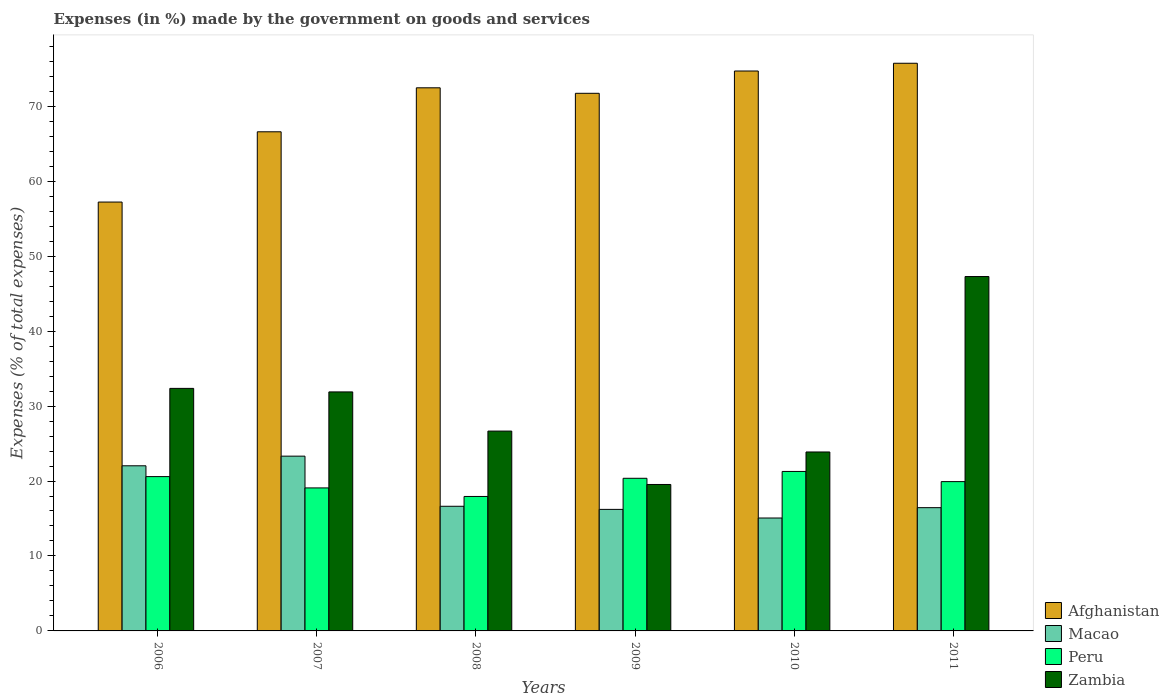How many groups of bars are there?
Your answer should be compact. 6. Are the number of bars on each tick of the X-axis equal?
Provide a short and direct response. Yes. How many bars are there on the 4th tick from the left?
Provide a short and direct response. 4. How many bars are there on the 4th tick from the right?
Give a very brief answer. 4. What is the percentage of expenses made by the government on goods and services in Zambia in 2009?
Ensure brevity in your answer.  19.54. Across all years, what is the maximum percentage of expenses made by the government on goods and services in Peru?
Ensure brevity in your answer.  21.28. Across all years, what is the minimum percentage of expenses made by the government on goods and services in Zambia?
Provide a short and direct response. 19.54. In which year was the percentage of expenses made by the government on goods and services in Zambia maximum?
Provide a succinct answer. 2011. What is the total percentage of expenses made by the government on goods and services in Afghanistan in the graph?
Your answer should be very brief. 418.42. What is the difference between the percentage of expenses made by the government on goods and services in Zambia in 2006 and that in 2007?
Your answer should be compact. 0.47. What is the difference between the percentage of expenses made by the government on goods and services in Afghanistan in 2008 and the percentage of expenses made by the government on goods and services in Zambia in 2006?
Offer a terse response. 40.1. What is the average percentage of expenses made by the government on goods and services in Zambia per year?
Provide a succinct answer. 30.27. In the year 2008, what is the difference between the percentage of expenses made by the government on goods and services in Zambia and percentage of expenses made by the government on goods and services in Afghanistan?
Keep it short and to the point. -45.8. What is the ratio of the percentage of expenses made by the government on goods and services in Peru in 2009 to that in 2010?
Provide a succinct answer. 0.96. Is the difference between the percentage of expenses made by the government on goods and services in Zambia in 2007 and 2010 greater than the difference between the percentage of expenses made by the government on goods and services in Afghanistan in 2007 and 2010?
Your response must be concise. Yes. What is the difference between the highest and the second highest percentage of expenses made by the government on goods and services in Zambia?
Keep it short and to the point. 14.92. What is the difference between the highest and the lowest percentage of expenses made by the government on goods and services in Peru?
Ensure brevity in your answer.  3.34. Is the sum of the percentage of expenses made by the government on goods and services in Zambia in 2008 and 2010 greater than the maximum percentage of expenses made by the government on goods and services in Peru across all years?
Give a very brief answer. Yes. What does the 4th bar from the left in 2007 represents?
Your answer should be very brief. Zambia. What does the 1st bar from the right in 2009 represents?
Offer a very short reply. Zambia. Is it the case that in every year, the sum of the percentage of expenses made by the government on goods and services in Afghanistan and percentage of expenses made by the government on goods and services in Peru is greater than the percentage of expenses made by the government on goods and services in Macao?
Offer a very short reply. Yes. How many bars are there?
Offer a very short reply. 24. Are all the bars in the graph horizontal?
Provide a succinct answer. No. Where does the legend appear in the graph?
Your answer should be compact. Bottom right. How many legend labels are there?
Provide a short and direct response. 4. What is the title of the graph?
Give a very brief answer. Expenses (in %) made by the government on goods and services. What is the label or title of the X-axis?
Give a very brief answer. Years. What is the label or title of the Y-axis?
Keep it short and to the point. Expenses (% of total expenses). What is the Expenses (% of total expenses) in Afghanistan in 2006?
Keep it short and to the point. 57.22. What is the Expenses (% of total expenses) in Macao in 2006?
Offer a very short reply. 22.03. What is the Expenses (% of total expenses) of Peru in 2006?
Provide a short and direct response. 20.59. What is the Expenses (% of total expenses) in Zambia in 2006?
Provide a succinct answer. 32.36. What is the Expenses (% of total expenses) in Afghanistan in 2007?
Provide a succinct answer. 66.59. What is the Expenses (% of total expenses) of Macao in 2007?
Keep it short and to the point. 23.32. What is the Expenses (% of total expenses) of Peru in 2007?
Ensure brevity in your answer.  19.08. What is the Expenses (% of total expenses) of Zambia in 2007?
Offer a very short reply. 31.89. What is the Expenses (% of total expenses) of Afghanistan in 2008?
Provide a succinct answer. 72.46. What is the Expenses (% of total expenses) in Macao in 2008?
Offer a terse response. 16.63. What is the Expenses (% of total expenses) in Peru in 2008?
Your response must be concise. 17.94. What is the Expenses (% of total expenses) of Zambia in 2008?
Make the answer very short. 26.66. What is the Expenses (% of total expenses) of Afghanistan in 2009?
Keep it short and to the point. 71.72. What is the Expenses (% of total expenses) in Macao in 2009?
Keep it short and to the point. 16.21. What is the Expenses (% of total expenses) in Peru in 2009?
Keep it short and to the point. 20.36. What is the Expenses (% of total expenses) of Zambia in 2009?
Make the answer very short. 19.54. What is the Expenses (% of total expenses) of Afghanistan in 2010?
Offer a very short reply. 74.7. What is the Expenses (% of total expenses) in Macao in 2010?
Your answer should be very brief. 15.06. What is the Expenses (% of total expenses) in Peru in 2010?
Offer a very short reply. 21.28. What is the Expenses (% of total expenses) in Zambia in 2010?
Offer a very short reply. 23.87. What is the Expenses (% of total expenses) in Afghanistan in 2011?
Ensure brevity in your answer.  75.73. What is the Expenses (% of total expenses) in Macao in 2011?
Offer a very short reply. 16.44. What is the Expenses (% of total expenses) in Peru in 2011?
Ensure brevity in your answer.  19.92. What is the Expenses (% of total expenses) of Zambia in 2011?
Ensure brevity in your answer.  47.28. Across all years, what is the maximum Expenses (% of total expenses) of Afghanistan?
Make the answer very short. 75.73. Across all years, what is the maximum Expenses (% of total expenses) of Macao?
Make the answer very short. 23.32. Across all years, what is the maximum Expenses (% of total expenses) in Peru?
Your answer should be compact. 21.28. Across all years, what is the maximum Expenses (% of total expenses) of Zambia?
Ensure brevity in your answer.  47.28. Across all years, what is the minimum Expenses (% of total expenses) of Afghanistan?
Your answer should be very brief. 57.22. Across all years, what is the minimum Expenses (% of total expenses) of Macao?
Your answer should be compact. 15.06. Across all years, what is the minimum Expenses (% of total expenses) of Peru?
Provide a succinct answer. 17.94. Across all years, what is the minimum Expenses (% of total expenses) in Zambia?
Make the answer very short. 19.54. What is the total Expenses (% of total expenses) of Afghanistan in the graph?
Provide a succinct answer. 418.42. What is the total Expenses (% of total expenses) in Macao in the graph?
Provide a succinct answer. 109.7. What is the total Expenses (% of total expenses) in Peru in the graph?
Keep it short and to the point. 119.16. What is the total Expenses (% of total expenses) of Zambia in the graph?
Your answer should be compact. 181.59. What is the difference between the Expenses (% of total expenses) of Afghanistan in 2006 and that in 2007?
Your response must be concise. -9.37. What is the difference between the Expenses (% of total expenses) in Macao in 2006 and that in 2007?
Offer a very short reply. -1.29. What is the difference between the Expenses (% of total expenses) of Peru in 2006 and that in 2007?
Give a very brief answer. 1.51. What is the difference between the Expenses (% of total expenses) in Zambia in 2006 and that in 2007?
Provide a succinct answer. 0.47. What is the difference between the Expenses (% of total expenses) in Afghanistan in 2006 and that in 2008?
Keep it short and to the point. -15.24. What is the difference between the Expenses (% of total expenses) in Macao in 2006 and that in 2008?
Keep it short and to the point. 5.4. What is the difference between the Expenses (% of total expenses) in Peru in 2006 and that in 2008?
Ensure brevity in your answer.  2.65. What is the difference between the Expenses (% of total expenses) of Zambia in 2006 and that in 2008?
Your answer should be compact. 5.7. What is the difference between the Expenses (% of total expenses) of Afghanistan in 2006 and that in 2009?
Your answer should be compact. -14.51. What is the difference between the Expenses (% of total expenses) in Macao in 2006 and that in 2009?
Offer a very short reply. 5.82. What is the difference between the Expenses (% of total expenses) in Peru in 2006 and that in 2009?
Provide a short and direct response. 0.22. What is the difference between the Expenses (% of total expenses) of Zambia in 2006 and that in 2009?
Provide a short and direct response. 12.82. What is the difference between the Expenses (% of total expenses) in Afghanistan in 2006 and that in 2010?
Make the answer very short. -17.48. What is the difference between the Expenses (% of total expenses) in Macao in 2006 and that in 2010?
Your response must be concise. 6.97. What is the difference between the Expenses (% of total expenses) of Peru in 2006 and that in 2010?
Provide a short and direct response. -0.69. What is the difference between the Expenses (% of total expenses) of Zambia in 2006 and that in 2010?
Provide a succinct answer. 8.48. What is the difference between the Expenses (% of total expenses) in Afghanistan in 2006 and that in 2011?
Provide a short and direct response. -18.52. What is the difference between the Expenses (% of total expenses) of Macao in 2006 and that in 2011?
Provide a succinct answer. 5.59. What is the difference between the Expenses (% of total expenses) in Peru in 2006 and that in 2011?
Offer a terse response. 0.67. What is the difference between the Expenses (% of total expenses) in Zambia in 2006 and that in 2011?
Keep it short and to the point. -14.92. What is the difference between the Expenses (% of total expenses) of Afghanistan in 2007 and that in 2008?
Provide a succinct answer. -5.87. What is the difference between the Expenses (% of total expenses) in Macao in 2007 and that in 2008?
Provide a succinct answer. 6.69. What is the difference between the Expenses (% of total expenses) in Peru in 2007 and that in 2008?
Give a very brief answer. 1.14. What is the difference between the Expenses (% of total expenses) of Zambia in 2007 and that in 2008?
Keep it short and to the point. 5.23. What is the difference between the Expenses (% of total expenses) in Afghanistan in 2007 and that in 2009?
Provide a short and direct response. -5.13. What is the difference between the Expenses (% of total expenses) of Macao in 2007 and that in 2009?
Your answer should be very brief. 7.1. What is the difference between the Expenses (% of total expenses) in Peru in 2007 and that in 2009?
Make the answer very short. -1.29. What is the difference between the Expenses (% of total expenses) of Zambia in 2007 and that in 2009?
Your response must be concise. 12.35. What is the difference between the Expenses (% of total expenses) in Afghanistan in 2007 and that in 2010?
Your answer should be very brief. -8.11. What is the difference between the Expenses (% of total expenses) of Macao in 2007 and that in 2010?
Give a very brief answer. 8.25. What is the difference between the Expenses (% of total expenses) in Peru in 2007 and that in 2010?
Provide a succinct answer. -2.2. What is the difference between the Expenses (% of total expenses) in Zambia in 2007 and that in 2010?
Your answer should be compact. 8.01. What is the difference between the Expenses (% of total expenses) of Afghanistan in 2007 and that in 2011?
Ensure brevity in your answer.  -9.14. What is the difference between the Expenses (% of total expenses) of Macao in 2007 and that in 2011?
Give a very brief answer. 6.87. What is the difference between the Expenses (% of total expenses) in Peru in 2007 and that in 2011?
Offer a very short reply. -0.84. What is the difference between the Expenses (% of total expenses) of Zambia in 2007 and that in 2011?
Your answer should be very brief. -15.39. What is the difference between the Expenses (% of total expenses) in Afghanistan in 2008 and that in 2009?
Provide a succinct answer. 0.73. What is the difference between the Expenses (% of total expenses) of Macao in 2008 and that in 2009?
Offer a very short reply. 0.41. What is the difference between the Expenses (% of total expenses) in Peru in 2008 and that in 2009?
Offer a terse response. -2.43. What is the difference between the Expenses (% of total expenses) of Zambia in 2008 and that in 2009?
Give a very brief answer. 7.12. What is the difference between the Expenses (% of total expenses) in Afghanistan in 2008 and that in 2010?
Offer a very short reply. -2.24. What is the difference between the Expenses (% of total expenses) in Macao in 2008 and that in 2010?
Keep it short and to the point. 1.56. What is the difference between the Expenses (% of total expenses) of Peru in 2008 and that in 2010?
Your response must be concise. -3.34. What is the difference between the Expenses (% of total expenses) of Zambia in 2008 and that in 2010?
Keep it short and to the point. 2.79. What is the difference between the Expenses (% of total expenses) in Afghanistan in 2008 and that in 2011?
Keep it short and to the point. -3.27. What is the difference between the Expenses (% of total expenses) in Macao in 2008 and that in 2011?
Ensure brevity in your answer.  0.18. What is the difference between the Expenses (% of total expenses) of Peru in 2008 and that in 2011?
Keep it short and to the point. -1.98. What is the difference between the Expenses (% of total expenses) in Zambia in 2008 and that in 2011?
Provide a succinct answer. -20.62. What is the difference between the Expenses (% of total expenses) of Afghanistan in 2009 and that in 2010?
Provide a short and direct response. -2.98. What is the difference between the Expenses (% of total expenses) of Macao in 2009 and that in 2010?
Provide a short and direct response. 1.15. What is the difference between the Expenses (% of total expenses) of Peru in 2009 and that in 2010?
Keep it short and to the point. -0.91. What is the difference between the Expenses (% of total expenses) of Zambia in 2009 and that in 2010?
Give a very brief answer. -4.34. What is the difference between the Expenses (% of total expenses) of Afghanistan in 2009 and that in 2011?
Keep it short and to the point. -4.01. What is the difference between the Expenses (% of total expenses) in Macao in 2009 and that in 2011?
Your answer should be very brief. -0.23. What is the difference between the Expenses (% of total expenses) in Peru in 2009 and that in 2011?
Offer a very short reply. 0.45. What is the difference between the Expenses (% of total expenses) in Zambia in 2009 and that in 2011?
Make the answer very short. -27.74. What is the difference between the Expenses (% of total expenses) of Afghanistan in 2010 and that in 2011?
Provide a succinct answer. -1.03. What is the difference between the Expenses (% of total expenses) of Macao in 2010 and that in 2011?
Your response must be concise. -1.38. What is the difference between the Expenses (% of total expenses) of Peru in 2010 and that in 2011?
Provide a short and direct response. 1.36. What is the difference between the Expenses (% of total expenses) of Zambia in 2010 and that in 2011?
Keep it short and to the point. -23.41. What is the difference between the Expenses (% of total expenses) of Afghanistan in 2006 and the Expenses (% of total expenses) of Macao in 2007?
Make the answer very short. 33.9. What is the difference between the Expenses (% of total expenses) in Afghanistan in 2006 and the Expenses (% of total expenses) in Peru in 2007?
Your response must be concise. 38.14. What is the difference between the Expenses (% of total expenses) of Afghanistan in 2006 and the Expenses (% of total expenses) of Zambia in 2007?
Give a very brief answer. 25.33. What is the difference between the Expenses (% of total expenses) of Macao in 2006 and the Expenses (% of total expenses) of Peru in 2007?
Your answer should be very brief. 2.95. What is the difference between the Expenses (% of total expenses) of Macao in 2006 and the Expenses (% of total expenses) of Zambia in 2007?
Give a very brief answer. -9.86. What is the difference between the Expenses (% of total expenses) in Peru in 2006 and the Expenses (% of total expenses) in Zambia in 2007?
Your answer should be compact. -11.3. What is the difference between the Expenses (% of total expenses) of Afghanistan in 2006 and the Expenses (% of total expenses) of Macao in 2008?
Your response must be concise. 40.59. What is the difference between the Expenses (% of total expenses) of Afghanistan in 2006 and the Expenses (% of total expenses) of Peru in 2008?
Provide a succinct answer. 39.28. What is the difference between the Expenses (% of total expenses) in Afghanistan in 2006 and the Expenses (% of total expenses) in Zambia in 2008?
Offer a very short reply. 30.56. What is the difference between the Expenses (% of total expenses) in Macao in 2006 and the Expenses (% of total expenses) in Peru in 2008?
Ensure brevity in your answer.  4.09. What is the difference between the Expenses (% of total expenses) in Macao in 2006 and the Expenses (% of total expenses) in Zambia in 2008?
Your answer should be compact. -4.63. What is the difference between the Expenses (% of total expenses) in Peru in 2006 and the Expenses (% of total expenses) in Zambia in 2008?
Your response must be concise. -6.07. What is the difference between the Expenses (% of total expenses) of Afghanistan in 2006 and the Expenses (% of total expenses) of Macao in 2009?
Your answer should be compact. 41. What is the difference between the Expenses (% of total expenses) of Afghanistan in 2006 and the Expenses (% of total expenses) of Peru in 2009?
Your answer should be very brief. 36.85. What is the difference between the Expenses (% of total expenses) of Afghanistan in 2006 and the Expenses (% of total expenses) of Zambia in 2009?
Ensure brevity in your answer.  37.68. What is the difference between the Expenses (% of total expenses) of Macao in 2006 and the Expenses (% of total expenses) of Peru in 2009?
Provide a short and direct response. 1.67. What is the difference between the Expenses (% of total expenses) in Macao in 2006 and the Expenses (% of total expenses) in Zambia in 2009?
Your answer should be compact. 2.49. What is the difference between the Expenses (% of total expenses) in Peru in 2006 and the Expenses (% of total expenses) in Zambia in 2009?
Offer a terse response. 1.05. What is the difference between the Expenses (% of total expenses) in Afghanistan in 2006 and the Expenses (% of total expenses) in Macao in 2010?
Make the answer very short. 42.15. What is the difference between the Expenses (% of total expenses) of Afghanistan in 2006 and the Expenses (% of total expenses) of Peru in 2010?
Offer a very short reply. 35.94. What is the difference between the Expenses (% of total expenses) in Afghanistan in 2006 and the Expenses (% of total expenses) in Zambia in 2010?
Offer a very short reply. 33.34. What is the difference between the Expenses (% of total expenses) in Macao in 2006 and the Expenses (% of total expenses) in Peru in 2010?
Provide a succinct answer. 0.75. What is the difference between the Expenses (% of total expenses) in Macao in 2006 and the Expenses (% of total expenses) in Zambia in 2010?
Your response must be concise. -1.84. What is the difference between the Expenses (% of total expenses) in Peru in 2006 and the Expenses (% of total expenses) in Zambia in 2010?
Your response must be concise. -3.28. What is the difference between the Expenses (% of total expenses) of Afghanistan in 2006 and the Expenses (% of total expenses) of Macao in 2011?
Keep it short and to the point. 40.77. What is the difference between the Expenses (% of total expenses) in Afghanistan in 2006 and the Expenses (% of total expenses) in Peru in 2011?
Your response must be concise. 37.3. What is the difference between the Expenses (% of total expenses) of Afghanistan in 2006 and the Expenses (% of total expenses) of Zambia in 2011?
Offer a very short reply. 9.94. What is the difference between the Expenses (% of total expenses) of Macao in 2006 and the Expenses (% of total expenses) of Peru in 2011?
Keep it short and to the point. 2.11. What is the difference between the Expenses (% of total expenses) of Macao in 2006 and the Expenses (% of total expenses) of Zambia in 2011?
Your answer should be very brief. -25.25. What is the difference between the Expenses (% of total expenses) of Peru in 2006 and the Expenses (% of total expenses) of Zambia in 2011?
Ensure brevity in your answer.  -26.69. What is the difference between the Expenses (% of total expenses) of Afghanistan in 2007 and the Expenses (% of total expenses) of Macao in 2008?
Your answer should be very brief. 49.96. What is the difference between the Expenses (% of total expenses) in Afghanistan in 2007 and the Expenses (% of total expenses) in Peru in 2008?
Offer a terse response. 48.65. What is the difference between the Expenses (% of total expenses) of Afghanistan in 2007 and the Expenses (% of total expenses) of Zambia in 2008?
Keep it short and to the point. 39.93. What is the difference between the Expenses (% of total expenses) of Macao in 2007 and the Expenses (% of total expenses) of Peru in 2008?
Your answer should be compact. 5.38. What is the difference between the Expenses (% of total expenses) of Macao in 2007 and the Expenses (% of total expenses) of Zambia in 2008?
Your answer should be compact. -3.34. What is the difference between the Expenses (% of total expenses) of Peru in 2007 and the Expenses (% of total expenses) of Zambia in 2008?
Ensure brevity in your answer.  -7.58. What is the difference between the Expenses (% of total expenses) in Afghanistan in 2007 and the Expenses (% of total expenses) in Macao in 2009?
Ensure brevity in your answer.  50.38. What is the difference between the Expenses (% of total expenses) in Afghanistan in 2007 and the Expenses (% of total expenses) in Peru in 2009?
Offer a very short reply. 46.23. What is the difference between the Expenses (% of total expenses) in Afghanistan in 2007 and the Expenses (% of total expenses) in Zambia in 2009?
Ensure brevity in your answer.  47.05. What is the difference between the Expenses (% of total expenses) in Macao in 2007 and the Expenses (% of total expenses) in Peru in 2009?
Provide a short and direct response. 2.95. What is the difference between the Expenses (% of total expenses) of Macao in 2007 and the Expenses (% of total expenses) of Zambia in 2009?
Provide a succinct answer. 3.78. What is the difference between the Expenses (% of total expenses) in Peru in 2007 and the Expenses (% of total expenses) in Zambia in 2009?
Keep it short and to the point. -0.46. What is the difference between the Expenses (% of total expenses) in Afghanistan in 2007 and the Expenses (% of total expenses) in Macao in 2010?
Your response must be concise. 51.53. What is the difference between the Expenses (% of total expenses) of Afghanistan in 2007 and the Expenses (% of total expenses) of Peru in 2010?
Keep it short and to the point. 45.31. What is the difference between the Expenses (% of total expenses) in Afghanistan in 2007 and the Expenses (% of total expenses) in Zambia in 2010?
Make the answer very short. 42.72. What is the difference between the Expenses (% of total expenses) of Macao in 2007 and the Expenses (% of total expenses) of Peru in 2010?
Provide a succinct answer. 2.04. What is the difference between the Expenses (% of total expenses) in Macao in 2007 and the Expenses (% of total expenses) in Zambia in 2010?
Give a very brief answer. -0.56. What is the difference between the Expenses (% of total expenses) in Peru in 2007 and the Expenses (% of total expenses) in Zambia in 2010?
Ensure brevity in your answer.  -4.8. What is the difference between the Expenses (% of total expenses) in Afghanistan in 2007 and the Expenses (% of total expenses) in Macao in 2011?
Provide a short and direct response. 50.15. What is the difference between the Expenses (% of total expenses) of Afghanistan in 2007 and the Expenses (% of total expenses) of Peru in 2011?
Provide a succinct answer. 46.67. What is the difference between the Expenses (% of total expenses) in Afghanistan in 2007 and the Expenses (% of total expenses) in Zambia in 2011?
Ensure brevity in your answer.  19.31. What is the difference between the Expenses (% of total expenses) of Macao in 2007 and the Expenses (% of total expenses) of Peru in 2011?
Your answer should be compact. 3.4. What is the difference between the Expenses (% of total expenses) of Macao in 2007 and the Expenses (% of total expenses) of Zambia in 2011?
Offer a very short reply. -23.96. What is the difference between the Expenses (% of total expenses) of Peru in 2007 and the Expenses (% of total expenses) of Zambia in 2011?
Offer a terse response. -28.2. What is the difference between the Expenses (% of total expenses) of Afghanistan in 2008 and the Expenses (% of total expenses) of Macao in 2009?
Keep it short and to the point. 56.24. What is the difference between the Expenses (% of total expenses) of Afghanistan in 2008 and the Expenses (% of total expenses) of Peru in 2009?
Your answer should be very brief. 52.09. What is the difference between the Expenses (% of total expenses) in Afghanistan in 2008 and the Expenses (% of total expenses) in Zambia in 2009?
Keep it short and to the point. 52.92. What is the difference between the Expenses (% of total expenses) of Macao in 2008 and the Expenses (% of total expenses) of Peru in 2009?
Your response must be concise. -3.74. What is the difference between the Expenses (% of total expenses) of Macao in 2008 and the Expenses (% of total expenses) of Zambia in 2009?
Your answer should be compact. -2.91. What is the difference between the Expenses (% of total expenses) in Peru in 2008 and the Expenses (% of total expenses) in Zambia in 2009?
Ensure brevity in your answer.  -1.6. What is the difference between the Expenses (% of total expenses) in Afghanistan in 2008 and the Expenses (% of total expenses) in Macao in 2010?
Keep it short and to the point. 57.39. What is the difference between the Expenses (% of total expenses) of Afghanistan in 2008 and the Expenses (% of total expenses) of Peru in 2010?
Offer a very short reply. 51.18. What is the difference between the Expenses (% of total expenses) in Afghanistan in 2008 and the Expenses (% of total expenses) in Zambia in 2010?
Offer a very short reply. 48.59. What is the difference between the Expenses (% of total expenses) of Macao in 2008 and the Expenses (% of total expenses) of Peru in 2010?
Make the answer very short. -4.65. What is the difference between the Expenses (% of total expenses) of Macao in 2008 and the Expenses (% of total expenses) of Zambia in 2010?
Provide a succinct answer. -7.24. What is the difference between the Expenses (% of total expenses) of Peru in 2008 and the Expenses (% of total expenses) of Zambia in 2010?
Your answer should be very brief. -5.93. What is the difference between the Expenses (% of total expenses) in Afghanistan in 2008 and the Expenses (% of total expenses) in Macao in 2011?
Keep it short and to the point. 56.01. What is the difference between the Expenses (% of total expenses) of Afghanistan in 2008 and the Expenses (% of total expenses) of Peru in 2011?
Your answer should be compact. 52.54. What is the difference between the Expenses (% of total expenses) in Afghanistan in 2008 and the Expenses (% of total expenses) in Zambia in 2011?
Provide a succinct answer. 25.18. What is the difference between the Expenses (% of total expenses) in Macao in 2008 and the Expenses (% of total expenses) in Peru in 2011?
Keep it short and to the point. -3.29. What is the difference between the Expenses (% of total expenses) in Macao in 2008 and the Expenses (% of total expenses) in Zambia in 2011?
Give a very brief answer. -30.65. What is the difference between the Expenses (% of total expenses) in Peru in 2008 and the Expenses (% of total expenses) in Zambia in 2011?
Provide a short and direct response. -29.34. What is the difference between the Expenses (% of total expenses) of Afghanistan in 2009 and the Expenses (% of total expenses) of Macao in 2010?
Offer a terse response. 56.66. What is the difference between the Expenses (% of total expenses) of Afghanistan in 2009 and the Expenses (% of total expenses) of Peru in 2010?
Your response must be concise. 50.45. What is the difference between the Expenses (% of total expenses) of Afghanistan in 2009 and the Expenses (% of total expenses) of Zambia in 2010?
Provide a short and direct response. 47.85. What is the difference between the Expenses (% of total expenses) of Macao in 2009 and the Expenses (% of total expenses) of Peru in 2010?
Your answer should be compact. -5.06. What is the difference between the Expenses (% of total expenses) of Macao in 2009 and the Expenses (% of total expenses) of Zambia in 2010?
Ensure brevity in your answer.  -7.66. What is the difference between the Expenses (% of total expenses) of Peru in 2009 and the Expenses (% of total expenses) of Zambia in 2010?
Make the answer very short. -3.51. What is the difference between the Expenses (% of total expenses) in Afghanistan in 2009 and the Expenses (% of total expenses) in Macao in 2011?
Give a very brief answer. 55.28. What is the difference between the Expenses (% of total expenses) of Afghanistan in 2009 and the Expenses (% of total expenses) of Peru in 2011?
Your answer should be compact. 51.81. What is the difference between the Expenses (% of total expenses) of Afghanistan in 2009 and the Expenses (% of total expenses) of Zambia in 2011?
Provide a short and direct response. 24.45. What is the difference between the Expenses (% of total expenses) of Macao in 2009 and the Expenses (% of total expenses) of Peru in 2011?
Provide a succinct answer. -3.7. What is the difference between the Expenses (% of total expenses) in Macao in 2009 and the Expenses (% of total expenses) in Zambia in 2011?
Give a very brief answer. -31.06. What is the difference between the Expenses (% of total expenses) in Peru in 2009 and the Expenses (% of total expenses) in Zambia in 2011?
Keep it short and to the point. -26.91. What is the difference between the Expenses (% of total expenses) of Afghanistan in 2010 and the Expenses (% of total expenses) of Macao in 2011?
Make the answer very short. 58.26. What is the difference between the Expenses (% of total expenses) in Afghanistan in 2010 and the Expenses (% of total expenses) in Peru in 2011?
Offer a very short reply. 54.78. What is the difference between the Expenses (% of total expenses) in Afghanistan in 2010 and the Expenses (% of total expenses) in Zambia in 2011?
Offer a very short reply. 27.42. What is the difference between the Expenses (% of total expenses) of Macao in 2010 and the Expenses (% of total expenses) of Peru in 2011?
Your response must be concise. -4.85. What is the difference between the Expenses (% of total expenses) of Macao in 2010 and the Expenses (% of total expenses) of Zambia in 2011?
Provide a succinct answer. -32.21. What is the difference between the Expenses (% of total expenses) of Peru in 2010 and the Expenses (% of total expenses) of Zambia in 2011?
Provide a succinct answer. -26. What is the average Expenses (% of total expenses) in Afghanistan per year?
Ensure brevity in your answer.  69.74. What is the average Expenses (% of total expenses) in Macao per year?
Keep it short and to the point. 18.28. What is the average Expenses (% of total expenses) in Peru per year?
Make the answer very short. 19.86. What is the average Expenses (% of total expenses) in Zambia per year?
Your response must be concise. 30.27. In the year 2006, what is the difference between the Expenses (% of total expenses) of Afghanistan and Expenses (% of total expenses) of Macao?
Offer a very short reply. 35.19. In the year 2006, what is the difference between the Expenses (% of total expenses) in Afghanistan and Expenses (% of total expenses) in Peru?
Make the answer very short. 36.63. In the year 2006, what is the difference between the Expenses (% of total expenses) in Afghanistan and Expenses (% of total expenses) in Zambia?
Provide a short and direct response. 24.86. In the year 2006, what is the difference between the Expenses (% of total expenses) of Macao and Expenses (% of total expenses) of Peru?
Your answer should be very brief. 1.44. In the year 2006, what is the difference between the Expenses (% of total expenses) in Macao and Expenses (% of total expenses) in Zambia?
Provide a succinct answer. -10.33. In the year 2006, what is the difference between the Expenses (% of total expenses) in Peru and Expenses (% of total expenses) in Zambia?
Your answer should be very brief. -11.77. In the year 2007, what is the difference between the Expenses (% of total expenses) of Afghanistan and Expenses (% of total expenses) of Macao?
Give a very brief answer. 43.27. In the year 2007, what is the difference between the Expenses (% of total expenses) of Afghanistan and Expenses (% of total expenses) of Peru?
Offer a terse response. 47.51. In the year 2007, what is the difference between the Expenses (% of total expenses) in Afghanistan and Expenses (% of total expenses) in Zambia?
Your answer should be compact. 34.7. In the year 2007, what is the difference between the Expenses (% of total expenses) of Macao and Expenses (% of total expenses) of Peru?
Make the answer very short. 4.24. In the year 2007, what is the difference between the Expenses (% of total expenses) of Macao and Expenses (% of total expenses) of Zambia?
Your answer should be compact. -8.57. In the year 2007, what is the difference between the Expenses (% of total expenses) in Peru and Expenses (% of total expenses) in Zambia?
Keep it short and to the point. -12.81. In the year 2008, what is the difference between the Expenses (% of total expenses) of Afghanistan and Expenses (% of total expenses) of Macao?
Your answer should be very brief. 55.83. In the year 2008, what is the difference between the Expenses (% of total expenses) of Afghanistan and Expenses (% of total expenses) of Peru?
Your response must be concise. 54.52. In the year 2008, what is the difference between the Expenses (% of total expenses) in Afghanistan and Expenses (% of total expenses) in Zambia?
Your answer should be compact. 45.8. In the year 2008, what is the difference between the Expenses (% of total expenses) in Macao and Expenses (% of total expenses) in Peru?
Offer a very short reply. -1.31. In the year 2008, what is the difference between the Expenses (% of total expenses) of Macao and Expenses (% of total expenses) of Zambia?
Make the answer very short. -10.03. In the year 2008, what is the difference between the Expenses (% of total expenses) of Peru and Expenses (% of total expenses) of Zambia?
Your response must be concise. -8.72. In the year 2009, what is the difference between the Expenses (% of total expenses) of Afghanistan and Expenses (% of total expenses) of Macao?
Your response must be concise. 55.51. In the year 2009, what is the difference between the Expenses (% of total expenses) of Afghanistan and Expenses (% of total expenses) of Peru?
Offer a terse response. 51.36. In the year 2009, what is the difference between the Expenses (% of total expenses) of Afghanistan and Expenses (% of total expenses) of Zambia?
Your answer should be very brief. 52.19. In the year 2009, what is the difference between the Expenses (% of total expenses) of Macao and Expenses (% of total expenses) of Peru?
Your response must be concise. -4.15. In the year 2009, what is the difference between the Expenses (% of total expenses) of Macao and Expenses (% of total expenses) of Zambia?
Your answer should be very brief. -3.32. In the year 2009, what is the difference between the Expenses (% of total expenses) in Peru and Expenses (% of total expenses) in Zambia?
Your response must be concise. 0.83. In the year 2010, what is the difference between the Expenses (% of total expenses) of Afghanistan and Expenses (% of total expenses) of Macao?
Make the answer very short. 59.64. In the year 2010, what is the difference between the Expenses (% of total expenses) in Afghanistan and Expenses (% of total expenses) in Peru?
Provide a short and direct response. 53.42. In the year 2010, what is the difference between the Expenses (% of total expenses) of Afghanistan and Expenses (% of total expenses) of Zambia?
Ensure brevity in your answer.  50.83. In the year 2010, what is the difference between the Expenses (% of total expenses) in Macao and Expenses (% of total expenses) in Peru?
Your response must be concise. -6.21. In the year 2010, what is the difference between the Expenses (% of total expenses) of Macao and Expenses (% of total expenses) of Zambia?
Ensure brevity in your answer.  -8.81. In the year 2010, what is the difference between the Expenses (% of total expenses) in Peru and Expenses (% of total expenses) in Zambia?
Offer a very short reply. -2.6. In the year 2011, what is the difference between the Expenses (% of total expenses) of Afghanistan and Expenses (% of total expenses) of Macao?
Offer a terse response. 59.29. In the year 2011, what is the difference between the Expenses (% of total expenses) in Afghanistan and Expenses (% of total expenses) in Peru?
Keep it short and to the point. 55.82. In the year 2011, what is the difference between the Expenses (% of total expenses) of Afghanistan and Expenses (% of total expenses) of Zambia?
Make the answer very short. 28.45. In the year 2011, what is the difference between the Expenses (% of total expenses) of Macao and Expenses (% of total expenses) of Peru?
Your answer should be compact. -3.47. In the year 2011, what is the difference between the Expenses (% of total expenses) of Macao and Expenses (% of total expenses) of Zambia?
Offer a very short reply. -30.83. In the year 2011, what is the difference between the Expenses (% of total expenses) in Peru and Expenses (% of total expenses) in Zambia?
Offer a very short reply. -27.36. What is the ratio of the Expenses (% of total expenses) in Afghanistan in 2006 to that in 2007?
Your answer should be compact. 0.86. What is the ratio of the Expenses (% of total expenses) of Macao in 2006 to that in 2007?
Provide a succinct answer. 0.94. What is the ratio of the Expenses (% of total expenses) in Peru in 2006 to that in 2007?
Offer a very short reply. 1.08. What is the ratio of the Expenses (% of total expenses) of Zambia in 2006 to that in 2007?
Make the answer very short. 1.01. What is the ratio of the Expenses (% of total expenses) in Afghanistan in 2006 to that in 2008?
Ensure brevity in your answer.  0.79. What is the ratio of the Expenses (% of total expenses) in Macao in 2006 to that in 2008?
Give a very brief answer. 1.32. What is the ratio of the Expenses (% of total expenses) in Peru in 2006 to that in 2008?
Your response must be concise. 1.15. What is the ratio of the Expenses (% of total expenses) of Zambia in 2006 to that in 2008?
Make the answer very short. 1.21. What is the ratio of the Expenses (% of total expenses) of Afghanistan in 2006 to that in 2009?
Provide a short and direct response. 0.8. What is the ratio of the Expenses (% of total expenses) in Macao in 2006 to that in 2009?
Make the answer very short. 1.36. What is the ratio of the Expenses (% of total expenses) in Zambia in 2006 to that in 2009?
Give a very brief answer. 1.66. What is the ratio of the Expenses (% of total expenses) of Afghanistan in 2006 to that in 2010?
Keep it short and to the point. 0.77. What is the ratio of the Expenses (% of total expenses) in Macao in 2006 to that in 2010?
Provide a short and direct response. 1.46. What is the ratio of the Expenses (% of total expenses) of Zambia in 2006 to that in 2010?
Keep it short and to the point. 1.36. What is the ratio of the Expenses (% of total expenses) of Afghanistan in 2006 to that in 2011?
Your answer should be compact. 0.76. What is the ratio of the Expenses (% of total expenses) of Macao in 2006 to that in 2011?
Ensure brevity in your answer.  1.34. What is the ratio of the Expenses (% of total expenses) of Peru in 2006 to that in 2011?
Offer a very short reply. 1.03. What is the ratio of the Expenses (% of total expenses) in Zambia in 2006 to that in 2011?
Make the answer very short. 0.68. What is the ratio of the Expenses (% of total expenses) of Afghanistan in 2007 to that in 2008?
Your answer should be very brief. 0.92. What is the ratio of the Expenses (% of total expenses) of Macao in 2007 to that in 2008?
Your answer should be compact. 1.4. What is the ratio of the Expenses (% of total expenses) of Peru in 2007 to that in 2008?
Offer a terse response. 1.06. What is the ratio of the Expenses (% of total expenses) in Zambia in 2007 to that in 2008?
Offer a terse response. 1.2. What is the ratio of the Expenses (% of total expenses) in Afghanistan in 2007 to that in 2009?
Your answer should be compact. 0.93. What is the ratio of the Expenses (% of total expenses) of Macao in 2007 to that in 2009?
Your response must be concise. 1.44. What is the ratio of the Expenses (% of total expenses) in Peru in 2007 to that in 2009?
Your answer should be compact. 0.94. What is the ratio of the Expenses (% of total expenses) of Zambia in 2007 to that in 2009?
Ensure brevity in your answer.  1.63. What is the ratio of the Expenses (% of total expenses) in Afghanistan in 2007 to that in 2010?
Give a very brief answer. 0.89. What is the ratio of the Expenses (% of total expenses) in Macao in 2007 to that in 2010?
Your response must be concise. 1.55. What is the ratio of the Expenses (% of total expenses) in Peru in 2007 to that in 2010?
Provide a succinct answer. 0.9. What is the ratio of the Expenses (% of total expenses) of Zambia in 2007 to that in 2010?
Ensure brevity in your answer.  1.34. What is the ratio of the Expenses (% of total expenses) in Afghanistan in 2007 to that in 2011?
Ensure brevity in your answer.  0.88. What is the ratio of the Expenses (% of total expenses) in Macao in 2007 to that in 2011?
Provide a succinct answer. 1.42. What is the ratio of the Expenses (% of total expenses) in Peru in 2007 to that in 2011?
Your response must be concise. 0.96. What is the ratio of the Expenses (% of total expenses) of Zambia in 2007 to that in 2011?
Offer a terse response. 0.67. What is the ratio of the Expenses (% of total expenses) in Afghanistan in 2008 to that in 2009?
Your answer should be very brief. 1.01. What is the ratio of the Expenses (% of total expenses) of Macao in 2008 to that in 2009?
Offer a terse response. 1.03. What is the ratio of the Expenses (% of total expenses) of Peru in 2008 to that in 2009?
Your response must be concise. 0.88. What is the ratio of the Expenses (% of total expenses) in Zambia in 2008 to that in 2009?
Provide a succinct answer. 1.36. What is the ratio of the Expenses (% of total expenses) of Macao in 2008 to that in 2010?
Provide a succinct answer. 1.1. What is the ratio of the Expenses (% of total expenses) of Peru in 2008 to that in 2010?
Your response must be concise. 0.84. What is the ratio of the Expenses (% of total expenses) in Zambia in 2008 to that in 2010?
Offer a terse response. 1.12. What is the ratio of the Expenses (% of total expenses) of Afghanistan in 2008 to that in 2011?
Give a very brief answer. 0.96. What is the ratio of the Expenses (% of total expenses) in Macao in 2008 to that in 2011?
Your answer should be compact. 1.01. What is the ratio of the Expenses (% of total expenses) of Peru in 2008 to that in 2011?
Make the answer very short. 0.9. What is the ratio of the Expenses (% of total expenses) in Zambia in 2008 to that in 2011?
Your response must be concise. 0.56. What is the ratio of the Expenses (% of total expenses) in Afghanistan in 2009 to that in 2010?
Your answer should be compact. 0.96. What is the ratio of the Expenses (% of total expenses) of Macao in 2009 to that in 2010?
Your response must be concise. 1.08. What is the ratio of the Expenses (% of total expenses) of Peru in 2009 to that in 2010?
Provide a short and direct response. 0.96. What is the ratio of the Expenses (% of total expenses) in Zambia in 2009 to that in 2010?
Make the answer very short. 0.82. What is the ratio of the Expenses (% of total expenses) of Afghanistan in 2009 to that in 2011?
Offer a terse response. 0.95. What is the ratio of the Expenses (% of total expenses) of Macao in 2009 to that in 2011?
Give a very brief answer. 0.99. What is the ratio of the Expenses (% of total expenses) of Peru in 2009 to that in 2011?
Provide a succinct answer. 1.02. What is the ratio of the Expenses (% of total expenses) of Zambia in 2009 to that in 2011?
Your answer should be very brief. 0.41. What is the ratio of the Expenses (% of total expenses) in Afghanistan in 2010 to that in 2011?
Ensure brevity in your answer.  0.99. What is the ratio of the Expenses (% of total expenses) of Macao in 2010 to that in 2011?
Offer a very short reply. 0.92. What is the ratio of the Expenses (% of total expenses) in Peru in 2010 to that in 2011?
Your answer should be very brief. 1.07. What is the ratio of the Expenses (% of total expenses) of Zambia in 2010 to that in 2011?
Offer a very short reply. 0.5. What is the difference between the highest and the second highest Expenses (% of total expenses) of Afghanistan?
Provide a short and direct response. 1.03. What is the difference between the highest and the second highest Expenses (% of total expenses) in Macao?
Give a very brief answer. 1.29. What is the difference between the highest and the second highest Expenses (% of total expenses) of Peru?
Ensure brevity in your answer.  0.69. What is the difference between the highest and the second highest Expenses (% of total expenses) of Zambia?
Your answer should be compact. 14.92. What is the difference between the highest and the lowest Expenses (% of total expenses) in Afghanistan?
Offer a very short reply. 18.52. What is the difference between the highest and the lowest Expenses (% of total expenses) of Macao?
Your response must be concise. 8.25. What is the difference between the highest and the lowest Expenses (% of total expenses) in Peru?
Give a very brief answer. 3.34. What is the difference between the highest and the lowest Expenses (% of total expenses) in Zambia?
Keep it short and to the point. 27.74. 